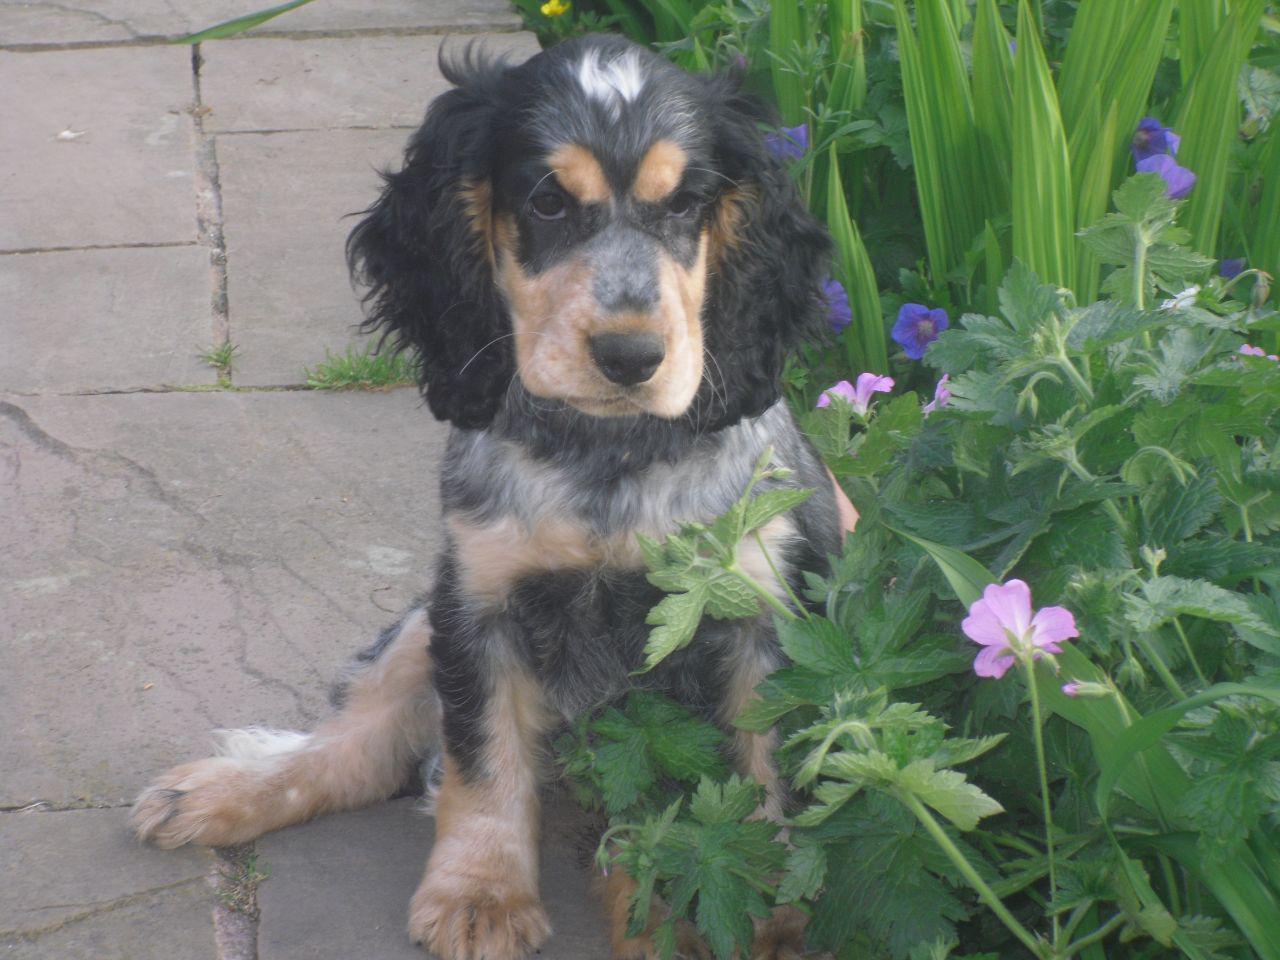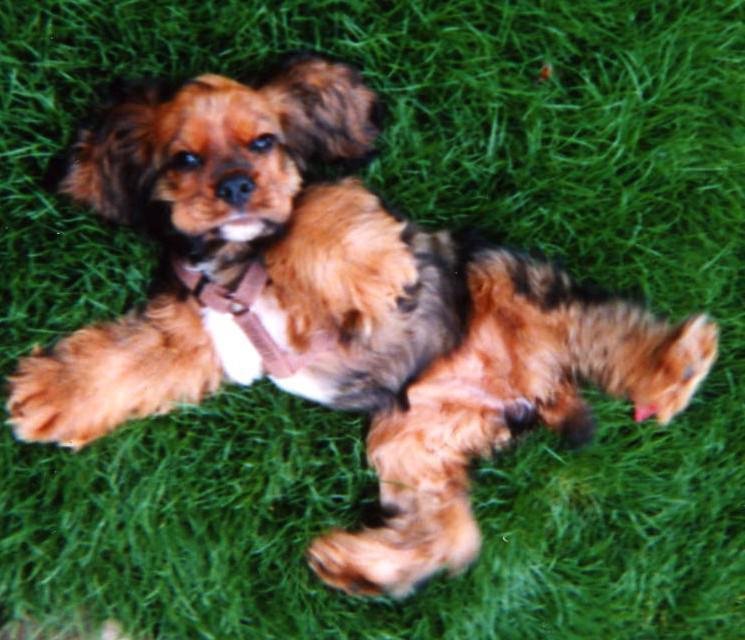The first image is the image on the left, the second image is the image on the right. For the images displayed, is the sentence "An image contains two dogs side by side." factually correct? Answer yes or no. No. The first image is the image on the left, the second image is the image on the right. For the images displayed, is the sentence "A human is holding a dog in one of the images." factually correct? Answer yes or no. No. 